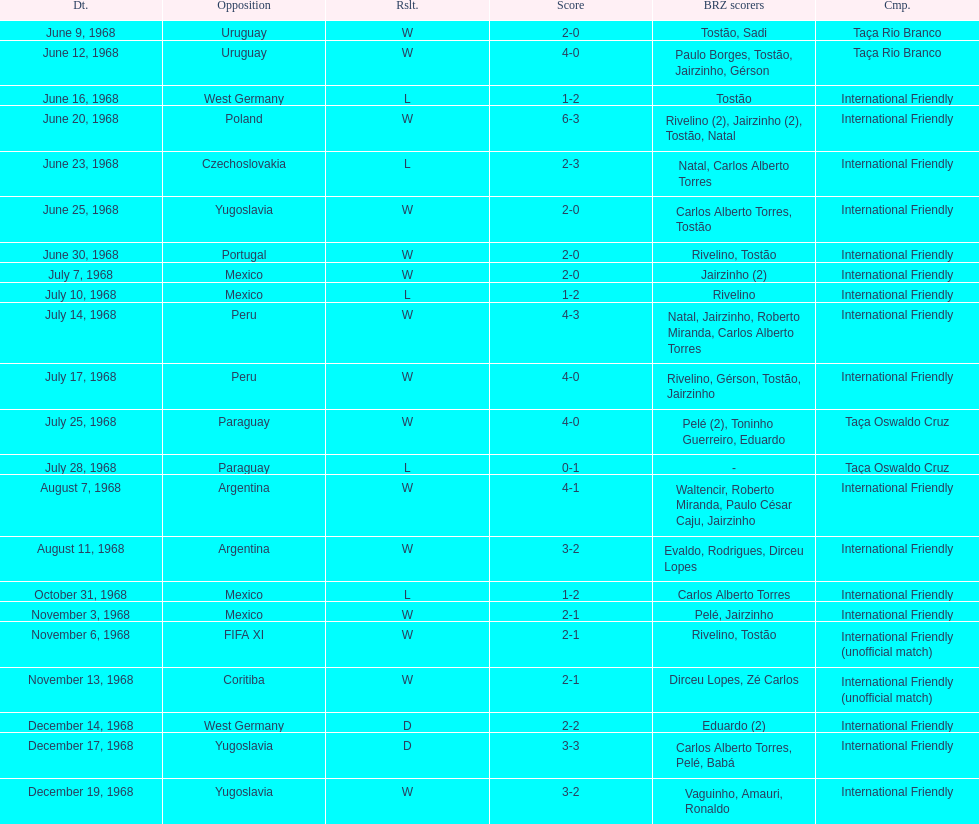Name the first competition ever played by brazil. Taça Rio Branco. 